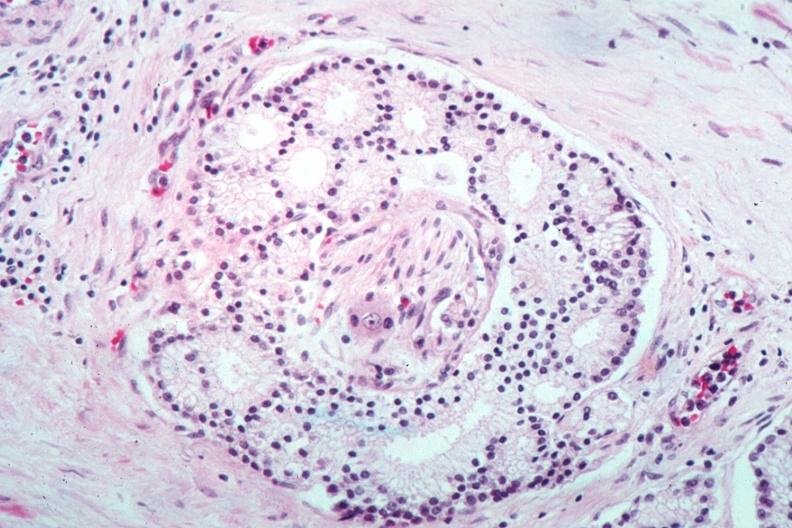s prostate present?
Answer the question using a single word or phrase. Yes 